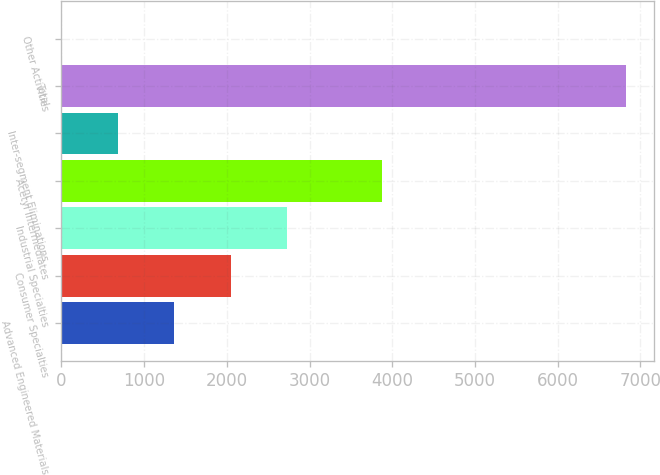<chart> <loc_0><loc_0><loc_500><loc_500><bar_chart><fcel>Advanced Engineered Materials<fcel>Consumer Specialties<fcel>Industrial Specialties<fcel>Acetyl Intermediates<fcel>Inter-segment Eliminations<fcel>Total<fcel>Other Activities<nl><fcel>1367.8<fcel>2049.7<fcel>2731.6<fcel>3875<fcel>685.9<fcel>6823<fcel>4<nl></chart> 